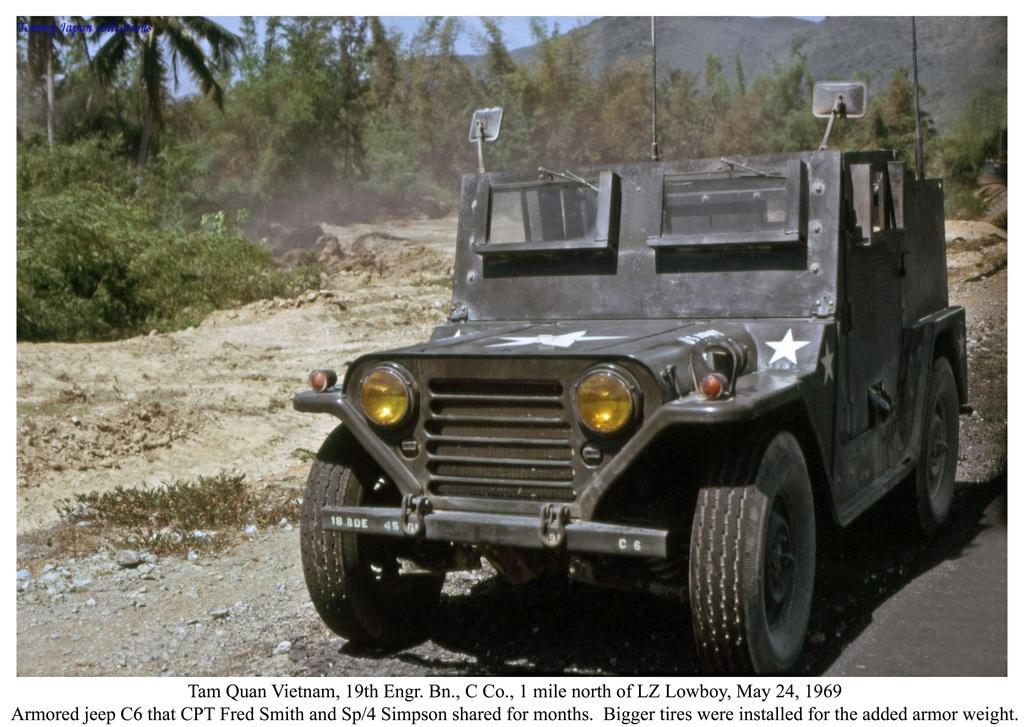What is parked on the road in the image? There is a vehicle parked on the road in the image. What can be seen in the background of the image? The background of the image includes the ground, plants, trees, hills, and the sky. What type of information is present at the bottom of the image? There is some information at the bottom of the image, but we cannot determine its content from the image alone. Can you see a collar on the wren in the image? There is no wren present in the image, so we cannot see a collar on it. 